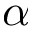<formula> <loc_0><loc_0><loc_500><loc_500>{ \alpha }</formula> 